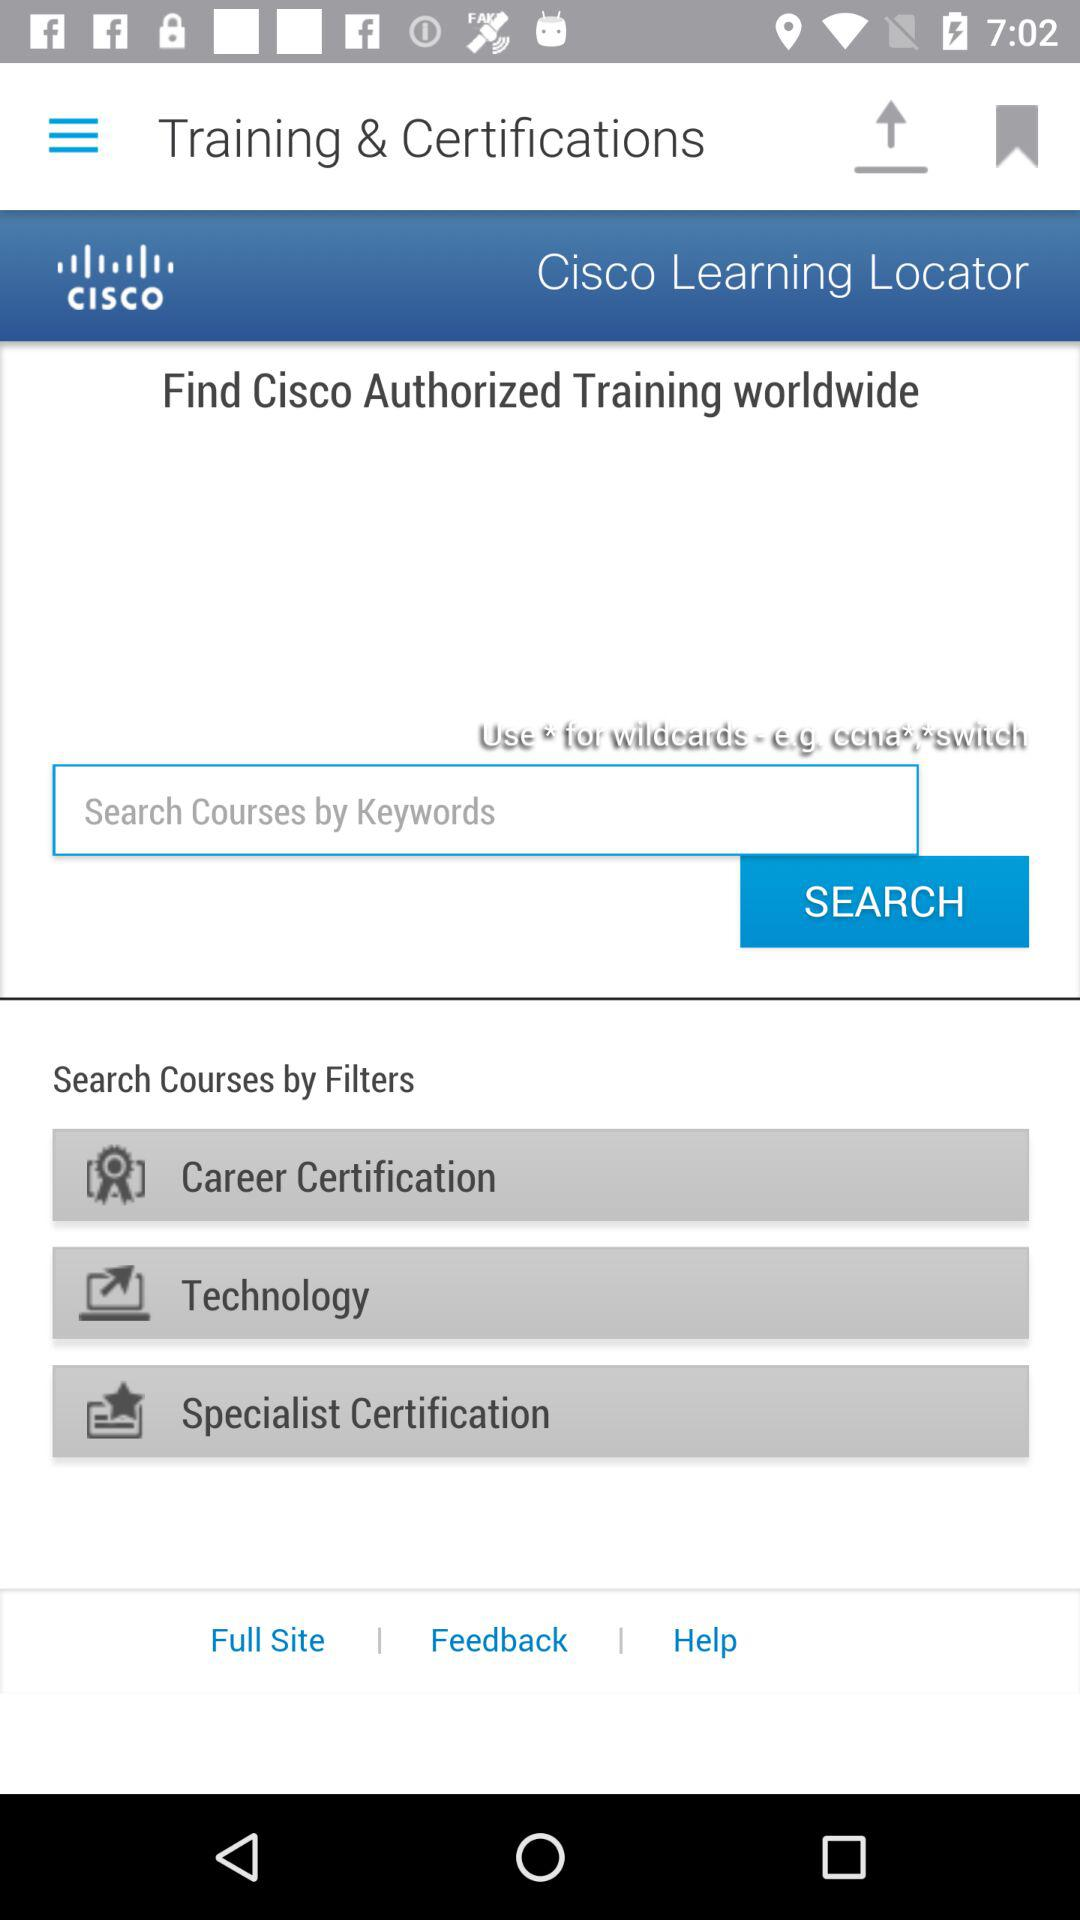What is the name of the application? The name of the application is "Cisco Learning Locator". 